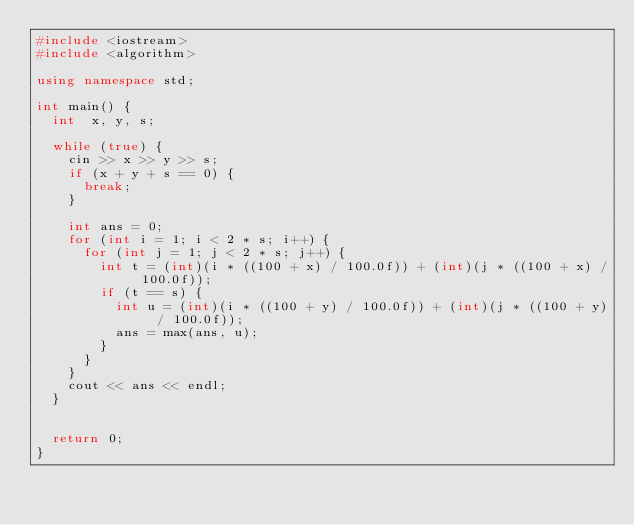<code> <loc_0><loc_0><loc_500><loc_500><_C++_>#include <iostream>
#include <algorithm>

using namespace std;

int main() {
  int  x, y, s;
  
  while (true) {
    cin >> x >> y >> s;
    if (x + y + s == 0) {
      break;
    }
    
    int ans = 0;
    for (int i = 1; i < 2 * s; i++) {
      for (int j = 1; j < 2 * s; j++) {
        int t = (int)(i * ((100 + x) / 100.0f)) + (int)(j * ((100 + x) / 100.0f));
        if (t == s) {
          int u = (int)(i * ((100 + y) / 100.0f)) + (int)(j * ((100 + y) / 100.0f));
          ans = max(ans, u);
        }   
      }
    }
    cout << ans << endl;
  }
  
  
  return 0;
}</code> 